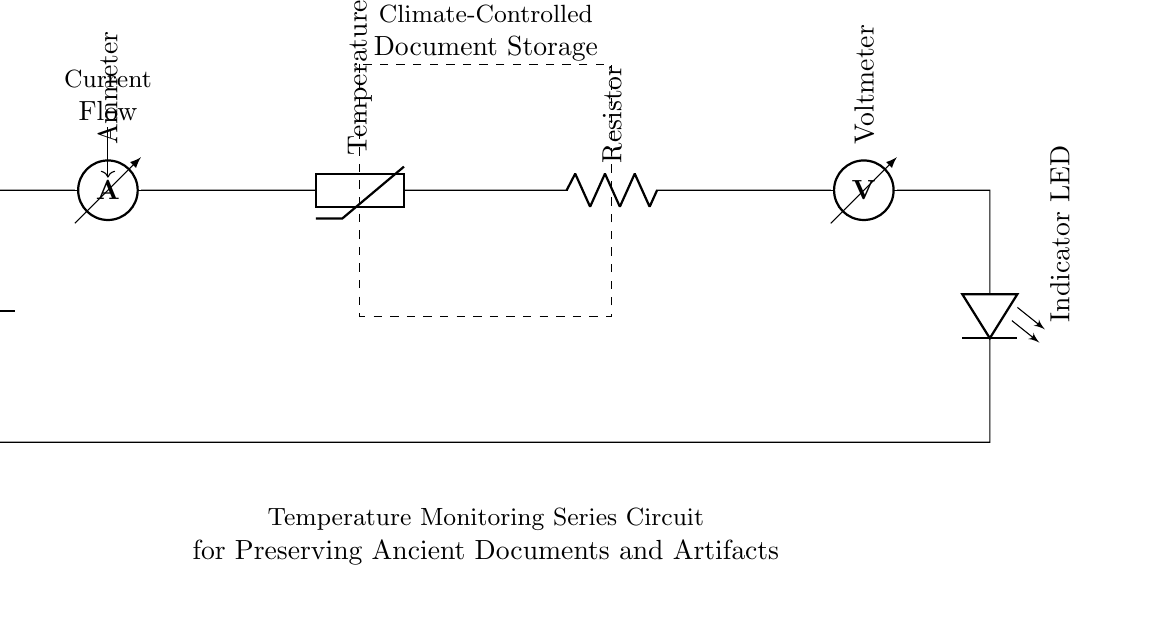What component measures current in this circuit? The component that measures current in the circuit is the ammeter, which is specifically designed to measure the flow of electric current.
Answer: Ammeter Which element provides temperature data in this circuit? The element that provides temperature data is the thermistor, a type of resistor whose resistance changes with temperature, allowing it to monitor temperature variations.
Answer: Thermistor What is the purpose of the LED in this circuit? The purpose of the LED is to serve as an indicator light that shows when the circuit is active or when a certain temperature threshold has been reached, providing a visual representation of the system's status.
Answer: Indicator What is the function of the resistor in the series? The function of the resistor is to limit the current flowing through the circuit, helping to protect sensitive components like the thermistor and LED from excessive current that could cause damage.
Answer: Limit current How does the current flow in this circuit? The current flows in a continuous path starting from the battery, through the ammeter, thermistor, resistor, and then to the voltmeter and LED, creating a closed-loop series circuit.
Answer: Closed-loop What is the total resistance if the thermistor has a resistance of 100 ohms and the resistor has a resistance of 50 ohms? The total resistance in a series circuit is the sum of the individual resistances. Thus, if the thermistor is 100 ohms and the resistor is 50 ohms, the total resistance is 100 plus 50, equaling 150 ohms.
Answer: 150 ohms 